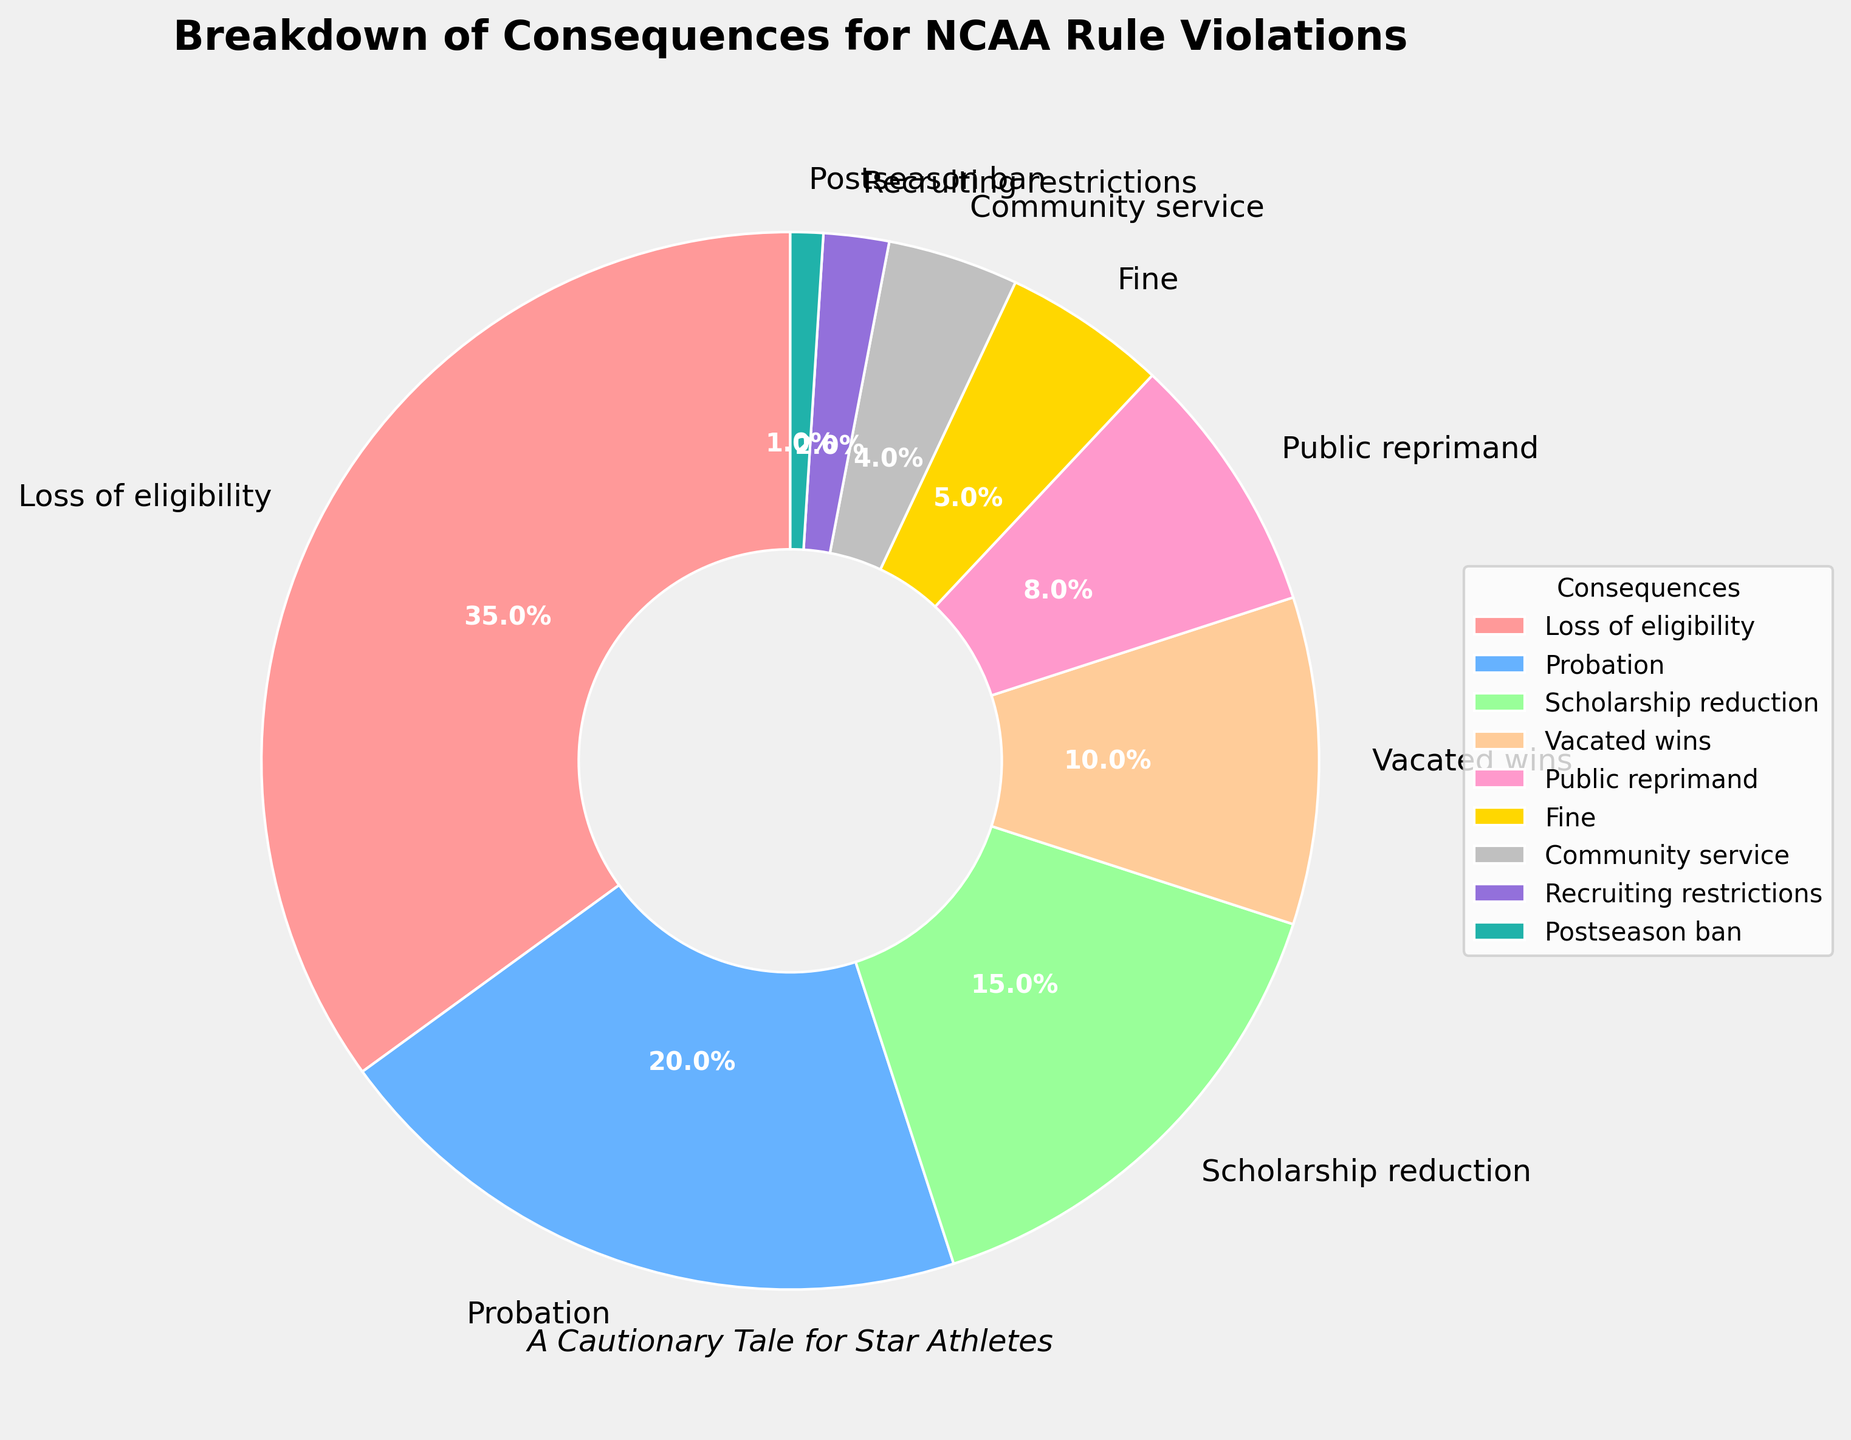Which consequence has the highest percentage? By looking at the pie chart, we identify the consequence that takes up the largest slice of the pie, which represents the highest percentage.
Answer: Loss of eligibility What is the combined percentage of Postseason ban and Recruiting restrictions? We locate Postseason ban (1%) and Recruiting restrictions (2%) on the pie chart and add their percentages: 1% + 2% = 3%.
Answer: 3% Which consequence is twice as significant as Fine? First, we determine the percentage for Fine, which is 5%. The consequence that holds 10% (twice of 5%) is Vacated wins.
Answer: Vacated wins How many consequences have a percentage below 10%? We count the segments of the pie chart that individually represent less than 10%. These are Public reprimand, Fine, Community service, Recruiting restrictions, and Postseason ban, totaling up to 5 segments.
Answer: 5 What is the difference in percentage between Probation and Scholarship reduction? The pie chart shows that Probation is 20% and Scholarship reduction is 15%. Subtracting these gives: 20% - 15% = 5%.
Answer: 5% Which consequence shares the same color as Fine? In the pie chart, Fine is typically represented with the yellow slice (#FFD700). We identify other segments by their colors or check the legend to see if they share the same color. None of the other consequences share this color.
Answer: None What percentage of consequences involves financial penalties (Fine and Scholarship reduction)? The pie chart indicates that Fine is 5% and Scholarship reduction is 15%. Adding these together gives: 5% + 15% = 20%.
Answer: 20% Is the proportion of Loss of eligibility greater than the combined total of Community service and Public reprimand? Loss of eligibility is 35%, Community service is 4%, and Public reprimand is 8%. First, find the sum of Community service and Public reprimand: 4% + 8% = 12%. Since 35% is greater than 12%, the proportion is indeed greater.
Answer: Yes 